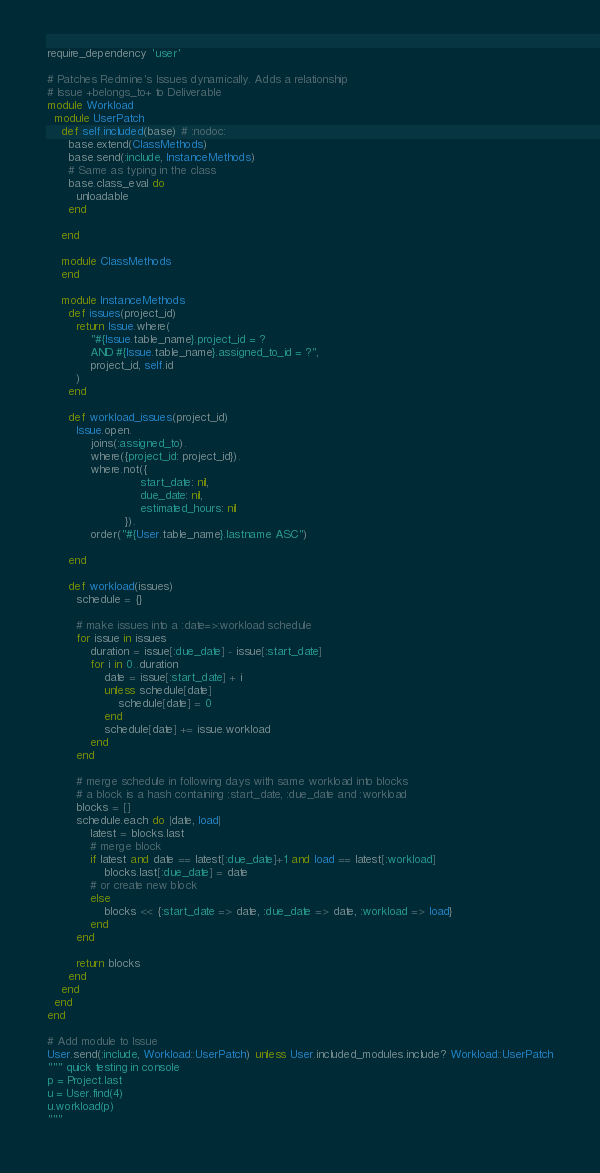Convert code to text. <code><loc_0><loc_0><loc_500><loc_500><_Ruby_>require_dependency 'user'

# Patches Redmine's Issues dynamically. Adds a relationship
# Issue +belongs_to+ to Deliverable
module Workload
  module UserPatch
    def self.included(base) # :nodoc:
      base.extend(ClassMethods)
      base.send(:include, InstanceMethods)
      # Same as typing in the class
      base.class_eval do
        unloadable
      end

    end

    module ClassMethods
    end

    module InstanceMethods
      def issues(project_id)
        return Issue.where(
            "#{Issue.table_name}.project_id = ?
            AND #{Issue.table_name}.assigned_to_id = ?",
            project_id, self.id
        )
      end

      def workload_issues(project_id)
        Issue.open.
            joins(:assigned_to).
            where({project_id: project_id}).
            where.not({
                          start_date: nil,
                          due_date: nil,
                          estimated_hours: nil
                      }).
            order("#{User.table_name}.lastname ASC")

      end

      def workload(issues)
        schedule = {}

        # make issues into a :date=>:workload schedule
        for issue in issues
            duration = issue[:due_date] - issue[:start_date]
            for i in 0..duration
                date = issue[:start_date] + i
                unless schedule[date]
                    schedule[date] = 0
                end
                schedule[date] += issue.workload
            end
        end

        # merge schedule in following days with same workload into blocks
        # a block is a hash containing :start_date, :due_date and :workload
        blocks = []
        schedule.each do |date, load|
            latest = blocks.last
            # merge block
            if latest and date == latest[:due_date]+1 and load == latest[:workload]
                blocks.last[:due_date] = date
            # or create new block
            else
                blocks << {:start_date => date, :due_date => date, :workload => load}
            end
        end

        return blocks
      end
    end
  end
end

# Add module to Issue
User.send(:include, Workload::UserPatch) unless User.included_modules.include? Workload::UserPatch
""" quick testing in console
p = Project.last
u = User.find(4)
u.workload(p)
"""
</code> 